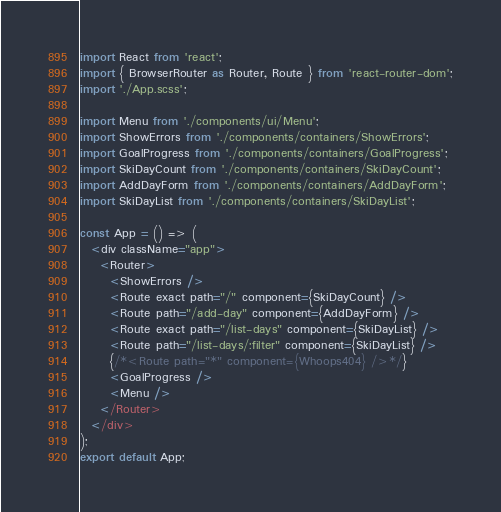Convert code to text. <code><loc_0><loc_0><loc_500><loc_500><_JavaScript_>import React from 'react';
import { BrowserRouter as Router, Route } from 'react-router-dom';
import './App.scss';

import Menu from './components/ui/Menu';
import ShowErrors from './components/containers/ShowErrors';
import GoalProgress from './components/containers/GoalProgress';
import SkiDayCount from './components/containers/SkiDayCount';
import AddDayForm from './components/containers/AddDayForm';
import SkiDayList from './components/containers/SkiDayList';

const App = () => (
  <div className="app">
    <Router>
      <ShowErrors />
      <Route exact path="/" component={SkiDayCount} />
      <Route path="/add-day" component={AddDayForm} />
      <Route exact path="/list-days" component={SkiDayList} />
      <Route path="/list-days/:filter" component={SkiDayList} />
      {/*<Route path="*" component={Whoops404} />*/}
      <GoalProgress />
      <Menu />
    </Router>
  </div>
);
export default App;
</code> 